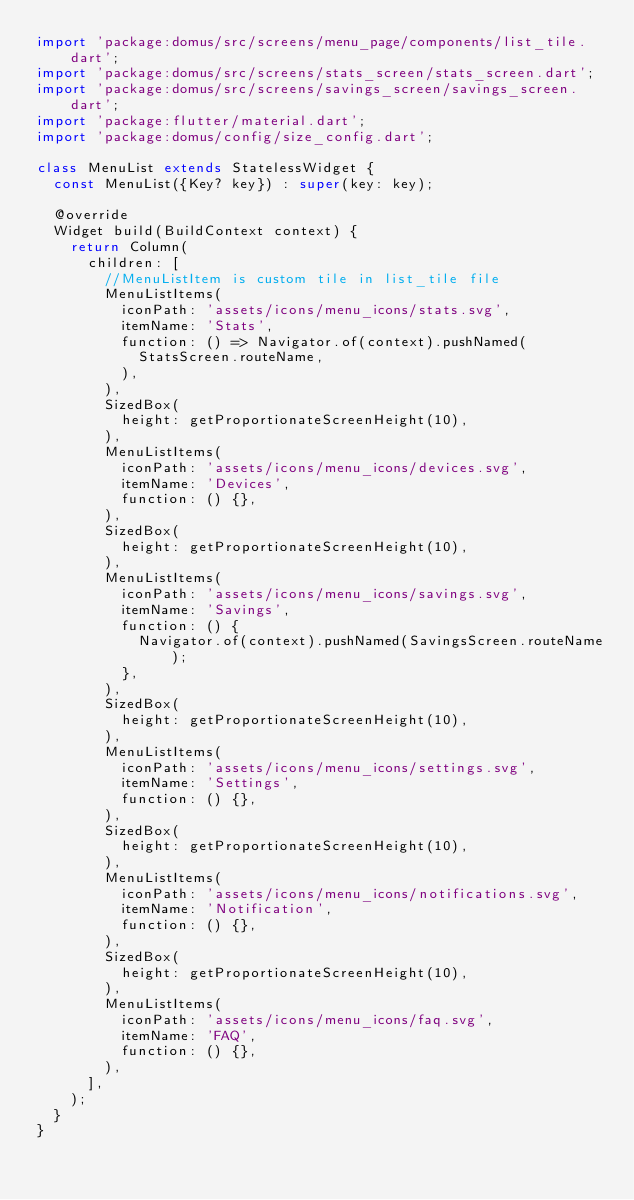<code> <loc_0><loc_0><loc_500><loc_500><_Dart_>import 'package:domus/src/screens/menu_page/components/list_tile.dart';
import 'package:domus/src/screens/stats_screen/stats_screen.dart';
import 'package:domus/src/screens/savings_screen/savings_screen.dart';
import 'package:flutter/material.dart';
import 'package:domus/config/size_config.dart';

class MenuList extends StatelessWidget {
  const MenuList({Key? key}) : super(key: key);

  @override
  Widget build(BuildContext context) {
    return Column(
      children: [
        //MenuListItem is custom tile in list_tile file
        MenuListItems(
          iconPath: 'assets/icons/menu_icons/stats.svg',
          itemName: 'Stats',
          function: () => Navigator.of(context).pushNamed(
            StatsScreen.routeName,
          ),
        ),
        SizedBox(
          height: getProportionateScreenHeight(10),
        ),
        MenuListItems(
          iconPath: 'assets/icons/menu_icons/devices.svg',
          itemName: 'Devices',
          function: () {},
        ),
        SizedBox(
          height: getProportionateScreenHeight(10),
        ),
        MenuListItems(
          iconPath: 'assets/icons/menu_icons/savings.svg',
          itemName: 'Savings',
          function: () {
            Navigator.of(context).pushNamed(SavingsScreen.routeName);
          },
        ),
        SizedBox(
          height: getProportionateScreenHeight(10),
        ),
        MenuListItems(
          iconPath: 'assets/icons/menu_icons/settings.svg',
          itemName: 'Settings',
          function: () {},
        ),
        SizedBox(
          height: getProportionateScreenHeight(10),
        ),
        MenuListItems(
          iconPath: 'assets/icons/menu_icons/notifications.svg',
          itemName: 'Notification',
          function: () {},
        ),
        SizedBox(
          height: getProportionateScreenHeight(10),
        ),
        MenuListItems(
          iconPath: 'assets/icons/menu_icons/faq.svg',
          itemName: 'FAQ',
          function: () {},
        ),
      ],
    );
  }
}
</code> 